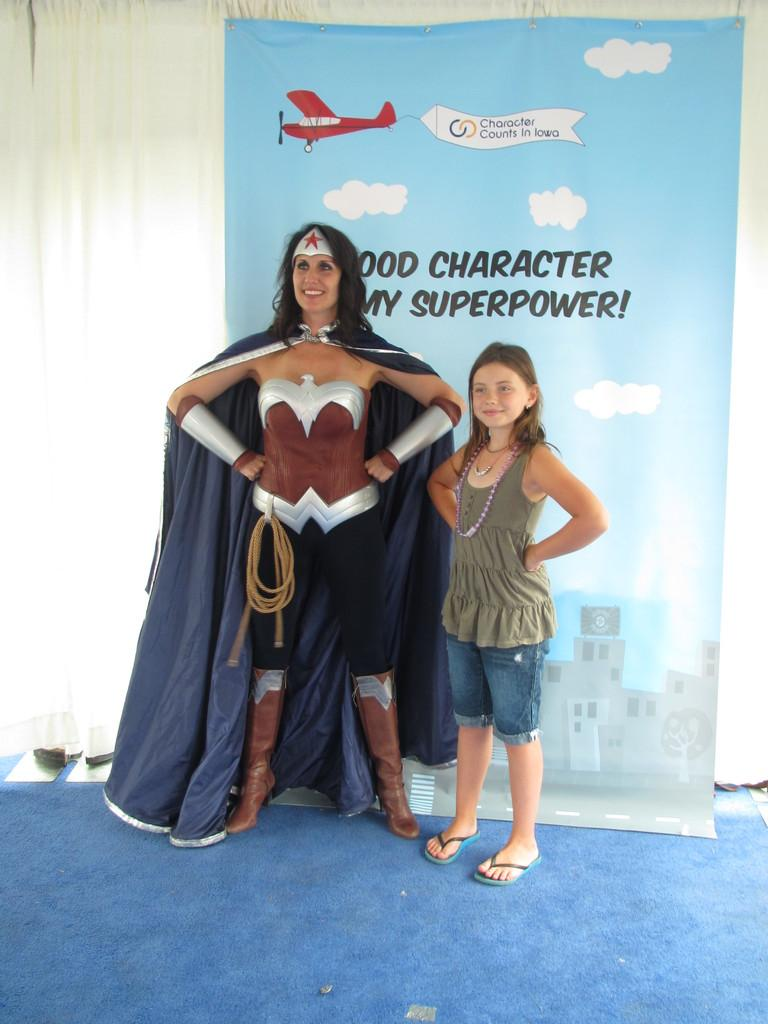<image>
Summarize the visual content of the image. Two people posing in front of a poster which says "Superpower" on it. 